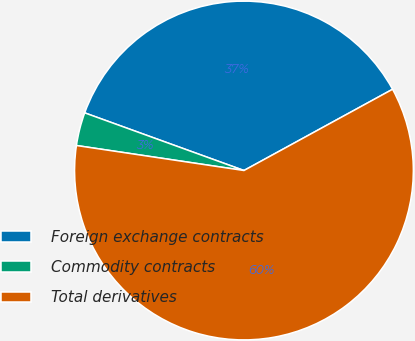<chart> <loc_0><loc_0><loc_500><loc_500><pie_chart><fcel>Foreign exchange contracts<fcel>Commodity contracts<fcel>Total derivatives<nl><fcel>36.51%<fcel>3.17%<fcel>60.32%<nl></chart> 